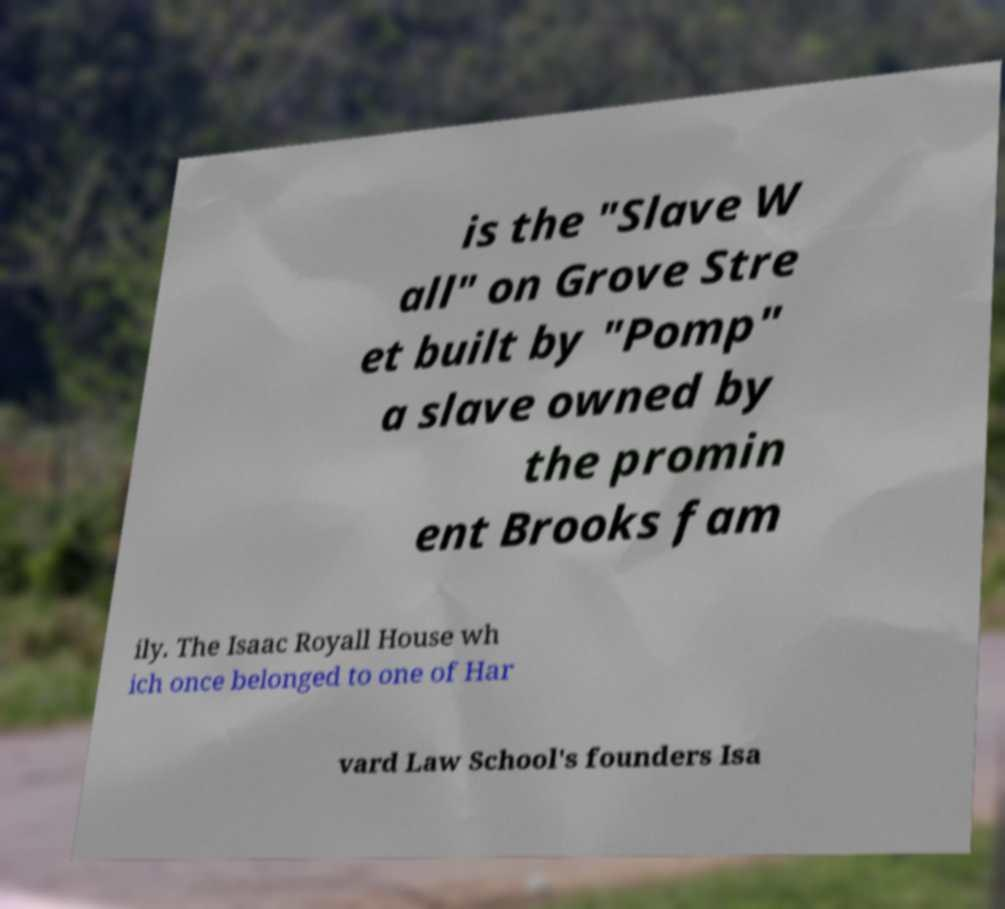For documentation purposes, I need the text within this image transcribed. Could you provide that? is the "Slave W all" on Grove Stre et built by "Pomp" a slave owned by the promin ent Brooks fam ily. The Isaac Royall House wh ich once belonged to one of Har vard Law School's founders Isa 